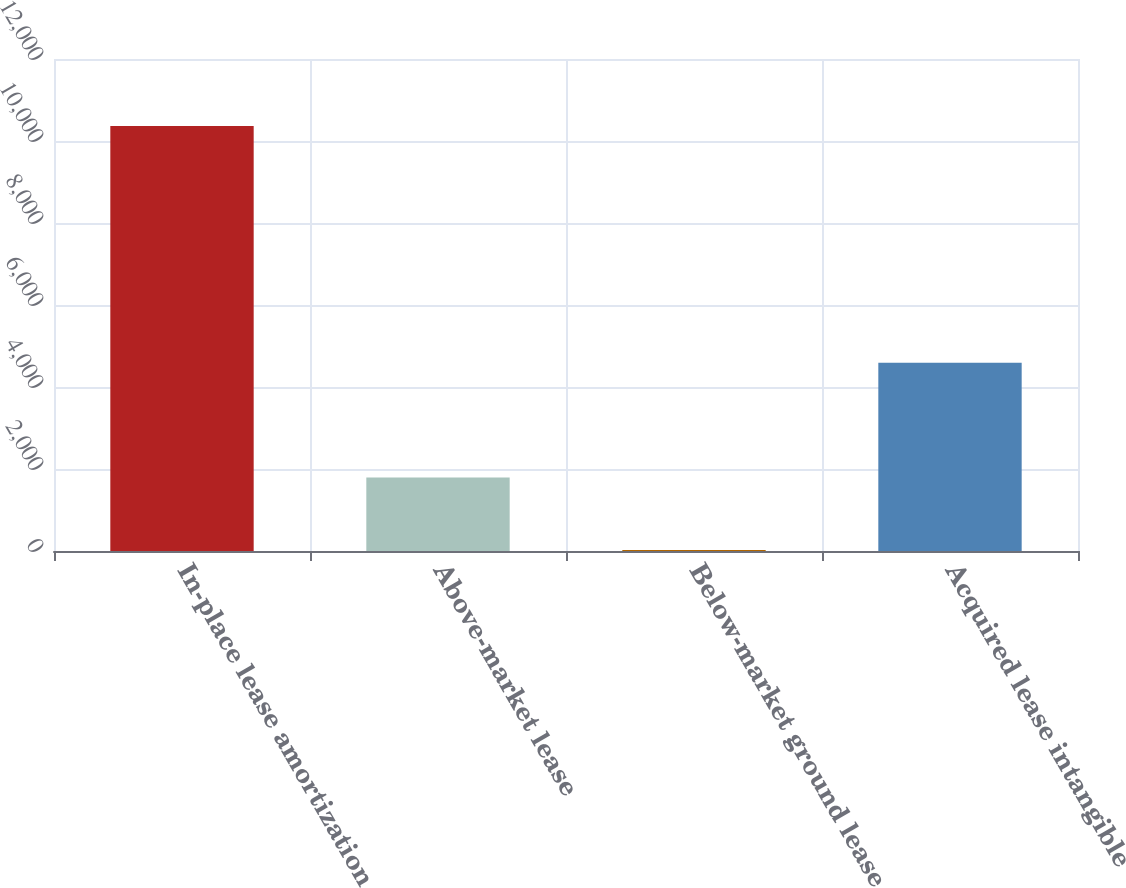Convert chart. <chart><loc_0><loc_0><loc_500><loc_500><bar_chart><fcel>In-place lease amortization<fcel>Above-market lease<fcel>Below-market ground lease<fcel>Acquired lease intangible<nl><fcel>10365<fcel>1795<fcel>23<fcel>4590<nl></chart> 